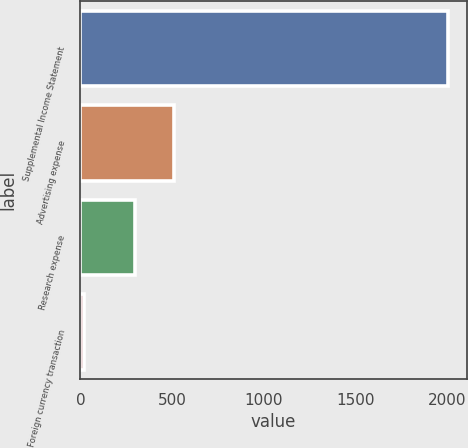<chart> <loc_0><loc_0><loc_500><loc_500><bar_chart><fcel>Supplemental Income Statement<fcel>Advertising expense<fcel>Research expense<fcel>Foreign currency transaction<nl><fcel>2008<fcel>512<fcel>297<fcel>18<nl></chart> 